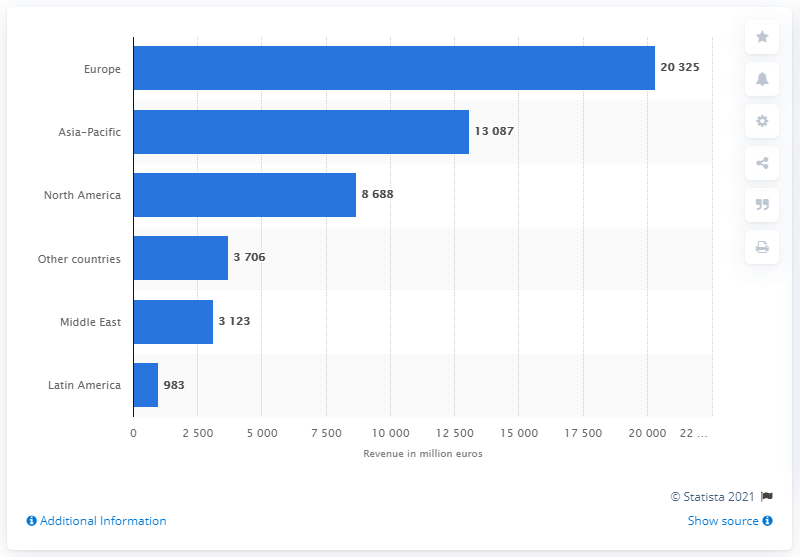Give some essential details in this illustration. Airbus reported collecting a total of 130,878 units from the Asia-Pacific region in 2020. Airbus collected more than 13 billion dollars from the Asia-Pacific region in 2020. 